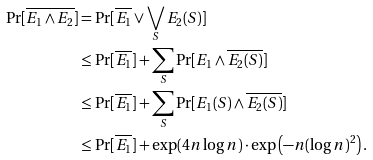<formula> <loc_0><loc_0><loc_500><loc_500>\Pr [ \overline { E _ { 1 } \wedge E _ { 2 } } ] & = \Pr [ \overline { E _ { 1 } } \vee \bigvee _ { S } E _ { 2 } ( S ) ] \\ & \leq \Pr [ \overline { E _ { 1 } } ] + \sum _ { S } \Pr [ E _ { 1 } \wedge \overline { E _ { 2 } ( S ) } ] \\ & \leq \Pr [ \overline { E _ { 1 } } ] + \sum _ { S } \Pr [ E _ { 1 } ( S ) \wedge \overline { E _ { 2 } ( S ) } ] \\ & \leq \Pr [ \overline { E _ { 1 } } ] + \exp ( 4 n \log n ) \cdot \exp \left ( - n ( \log n ) ^ { 2 } \right ) . \\</formula> 